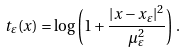<formula> <loc_0><loc_0><loc_500><loc_500>t _ { \varepsilon } ( x ) = \log \left ( 1 + \frac { | x - x _ { \varepsilon } | ^ { 2 } } { \mu _ { \varepsilon } ^ { 2 } } \right ) \, .</formula> 